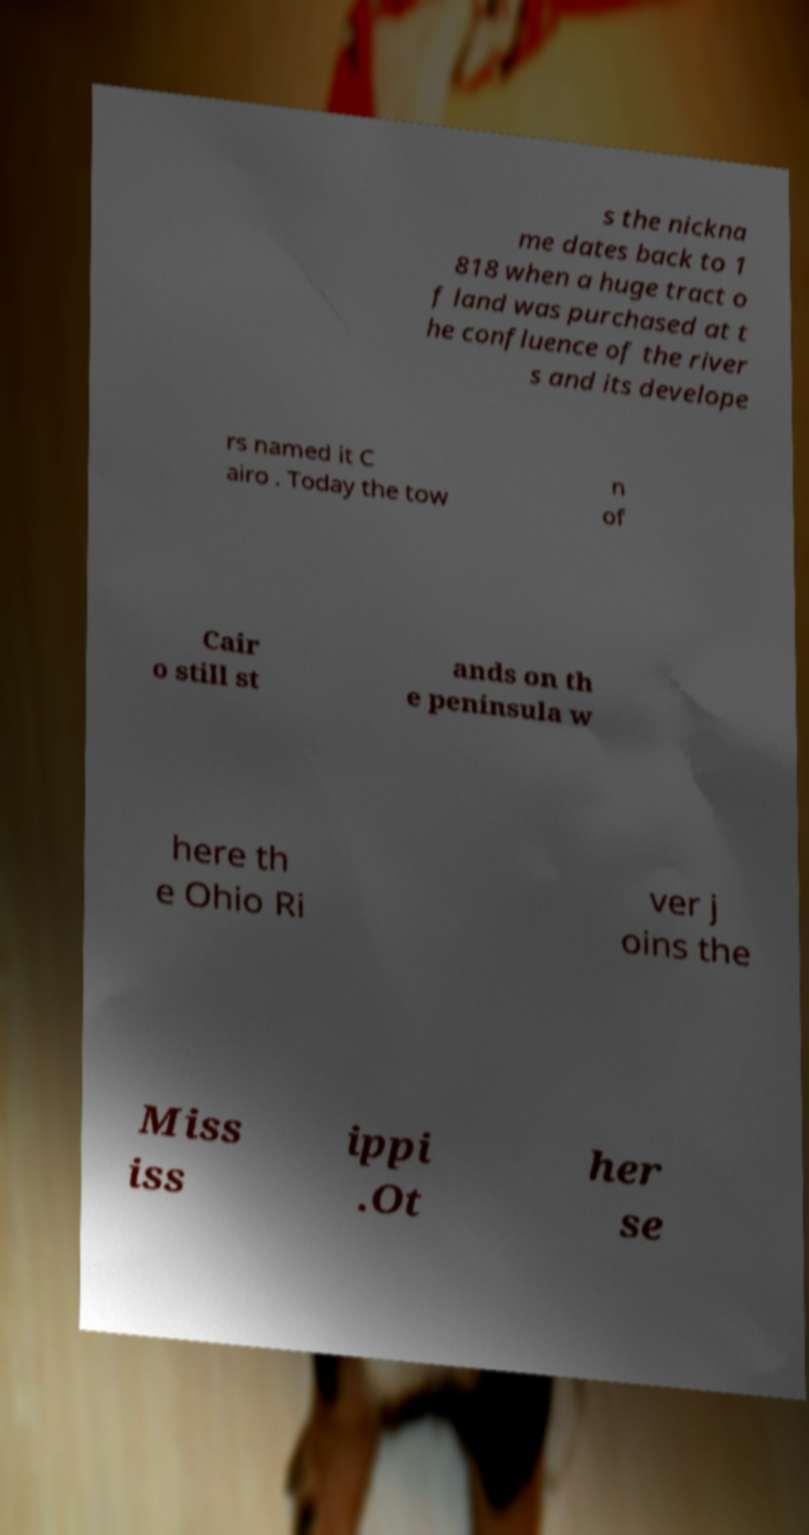What messages or text are displayed in this image? I need them in a readable, typed format. s the nickna me dates back to 1 818 when a huge tract o f land was purchased at t he confluence of the river s and its develope rs named it C airo . Today the tow n of Cair o still st ands on th e peninsula w here th e Ohio Ri ver j oins the Miss iss ippi .Ot her se 